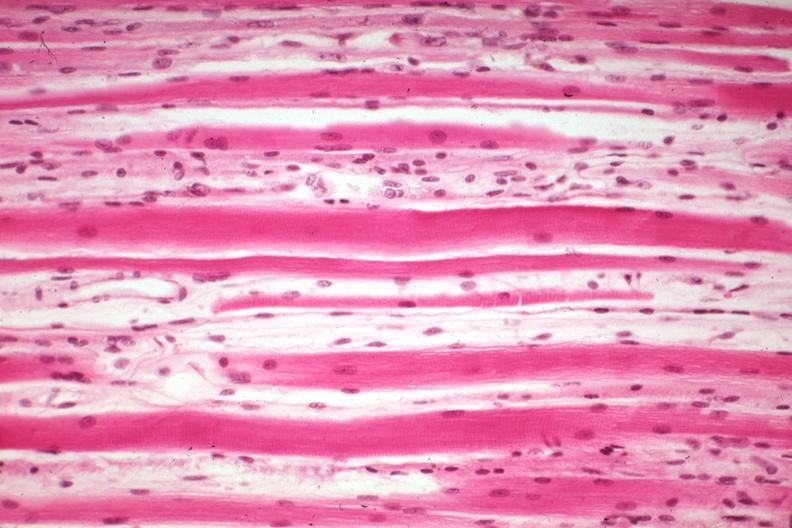what does this image show?
Answer the question using a single word or phrase. High excellent steroid induced atrophy 